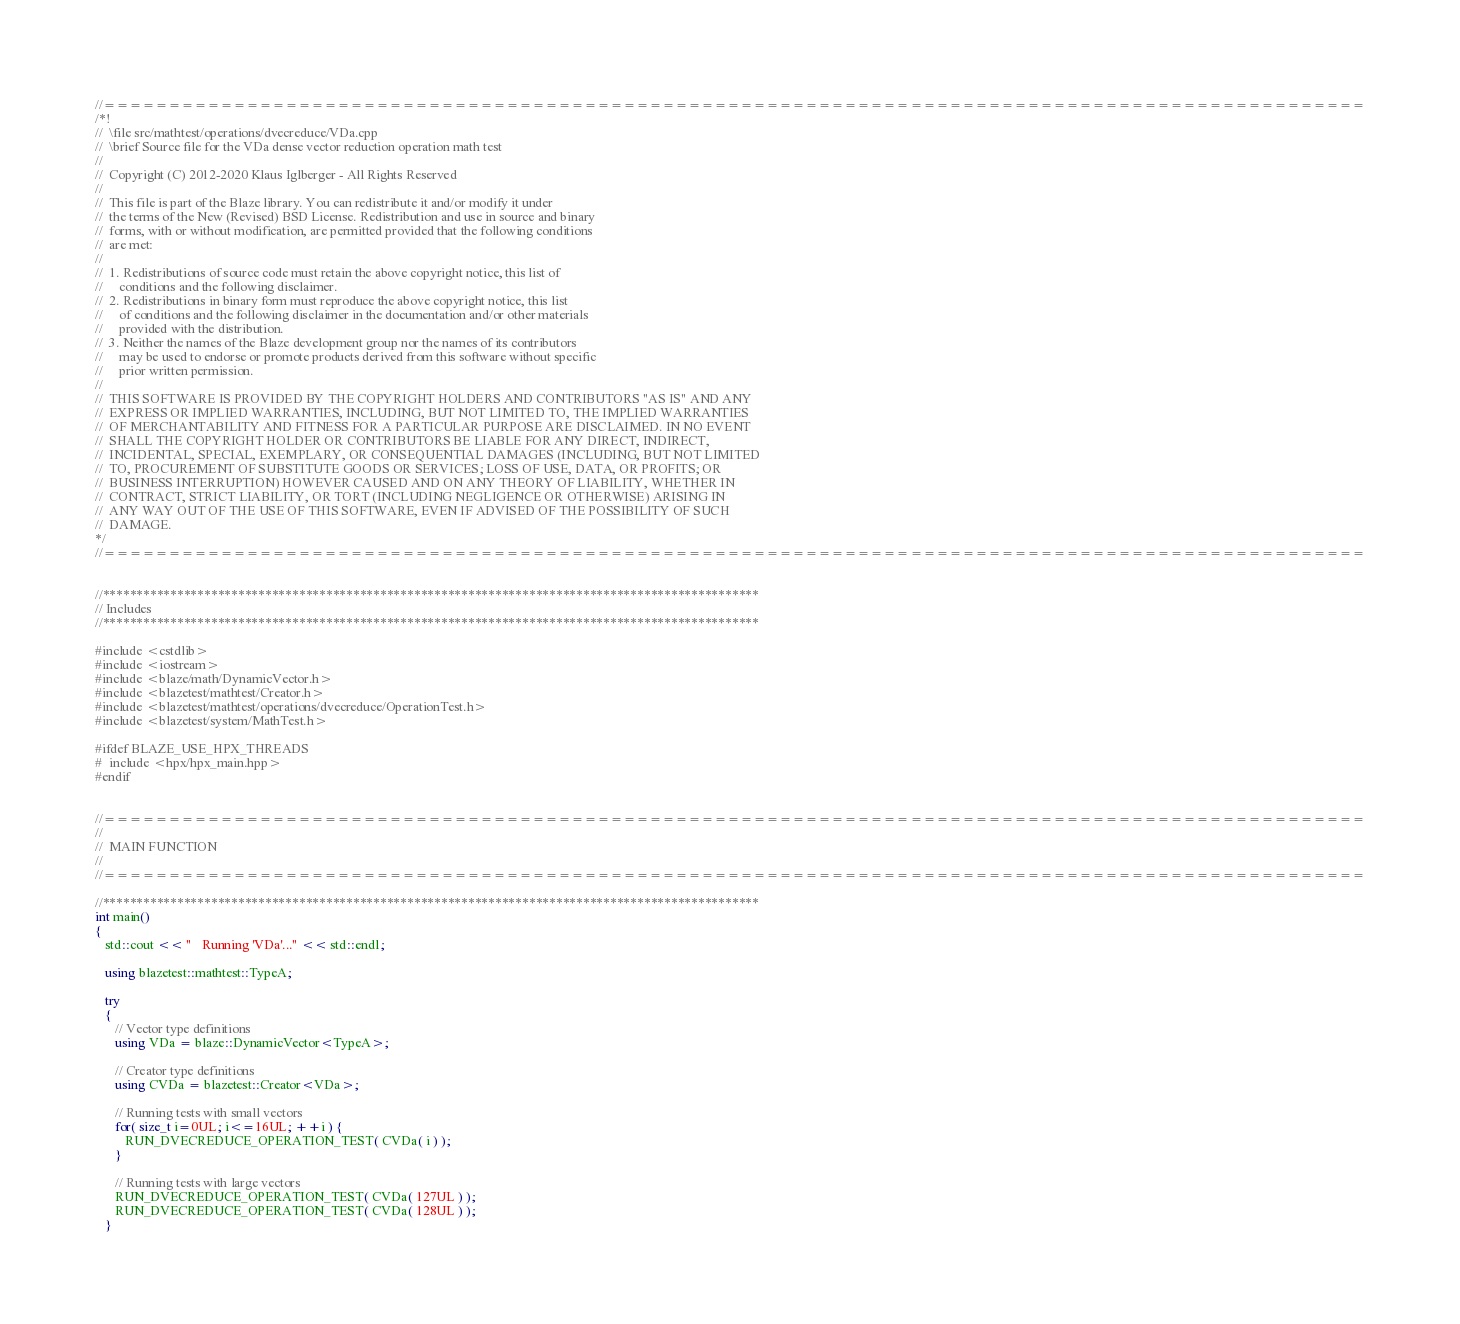Convert code to text. <code><loc_0><loc_0><loc_500><loc_500><_C++_>//=================================================================================================
/*!
//  \file src/mathtest/operations/dvecreduce/VDa.cpp
//  \brief Source file for the VDa dense vector reduction operation math test
//
//  Copyright (C) 2012-2020 Klaus Iglberger - All Rights Reserved
//
//  This file is part of the Blaze library. You can redistribute it and/or modify it under
//  the terms of the New (Revised) BSD License. Redistribution and use in source and binary
//  forms, with or without modification, are permitted provided that the following conditions
//  are met:
//
//  1. Redistributions of source code must retain the above copyright notice, this list of
//     conditions and the following disclaimer.
//  2. Redistributions in binary form must reproduce the above copyright notice, this list
//     of conditions and the following disclaimer in the documentation and/or other materials
//     provided with the distribution.
//  3. Neither the names of the Blaze development group nor the names of its contributors
//     may be used to endorse or promote products derived from this software without specific
//     prior written permission.
//
//  THIS SOFTWARE IS PROVIDED BY THE COPYRIGHT HOLDERS AND CONTRIBUTORS "AS IS" AND ANY
//  EXPRESS OR IMPLIED WARRANTIES, INCLUDING, BUT NOT LIMITED TO, THE IMPLIED WARRANTIES
//  OF MERCHANTABILITY AND FITNESS FOR A PARTICULAR PURPOSE ARE DISCLAIMED. IN NO EVENT
//  SHALL THE COPYRIGHT HOLDER OR CONTRIBUTORS BE LIABLE FOR ANY DIRECT, INDIRECT,
//  INCIDENTAL, SPECIAL, EXEMPLARY, OR CONSEQUENTIAL DAMAGES (INCLUDING, BUT NOT LIMITED
//  TO, PROCUREMENT OF SUBSTITUTE GOODS OR SERVICES; LOSS OF USE, DATA, OR PROFITS; OR
//  BUSINESS INTERRUPTION) HOWEVER CAUSED AND ON ANY THEORY OF LIABILITY, WHETHER IN
//  CONTRACT, STRICT LIABILITY, OR TORT (INCLUDING NEGLIGENCE OR OTHERWISE) ARISING IN
//  ANY WAY OUT OF THE USE OF THIS SOFTWARE, EVEN IF ADVISED OF THE POSSIBILITY OF SUCH
//  DAMAGE.
*/
//=================================================================================================


//*************************************************************************************************
// Includes
//*************************************************************************************************

#include <cstdlib>
#include <iostream>
#include <blaze/math/DynamicVector.h>
#include <blazetest/mathtest/Creator.h>
#include <blazetest/mathtest/operations/dvecreduce/OperationTest.h>
#include <blazetest/system/MathTest.h>

#ifdef BLAZE_USE_HPX_THREADS
#  include <hpx/hpx_main.hpp>
#endif


//=================================================================================================
//
//  MAIN FUNCTION
//
//=================================================================================================

//*************************************************************************************************
int main()
{
   std::cout << "   Running 'VDa'..." << std::endl;

   using blazetest::mathtest::TypeA;

   try
   {
      // Vector type definitions
      using VDa = blaze::DynamicVector<TypeA>;

      // Creator type definitions
      using CVDa = blazetest::Creator<VDa>;

      // Running tests with small vectors
      for( size_t i=0UL; i<=16UL; ++i ) {
         RUN_DVECREDUCE_OPERATION_TEST( CVDa( i ) );
      }

      // Running tests with large vectors
      RUN_DVECREDUCE_OPERATION_TEST( CVDa( 127UL ) );
      RUN_DVECREDUCE_OPERATION_TEST( CVDa( 128UL ) );
   }</code> 